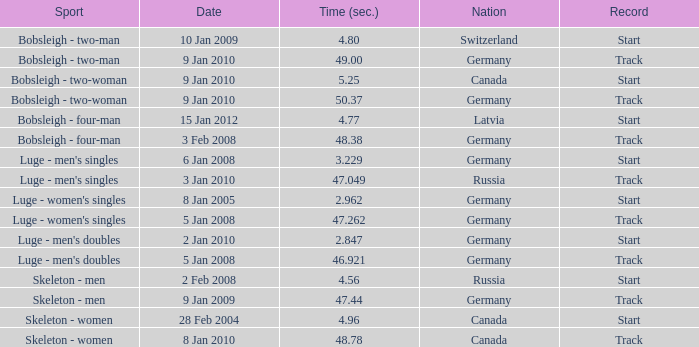Which nation finished with a time of 47.049? Russia. 